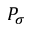Convert formula to latex. <formula><loc_0><loc_0><loc_500><loc_500>P _ { \sigma }</formula> 